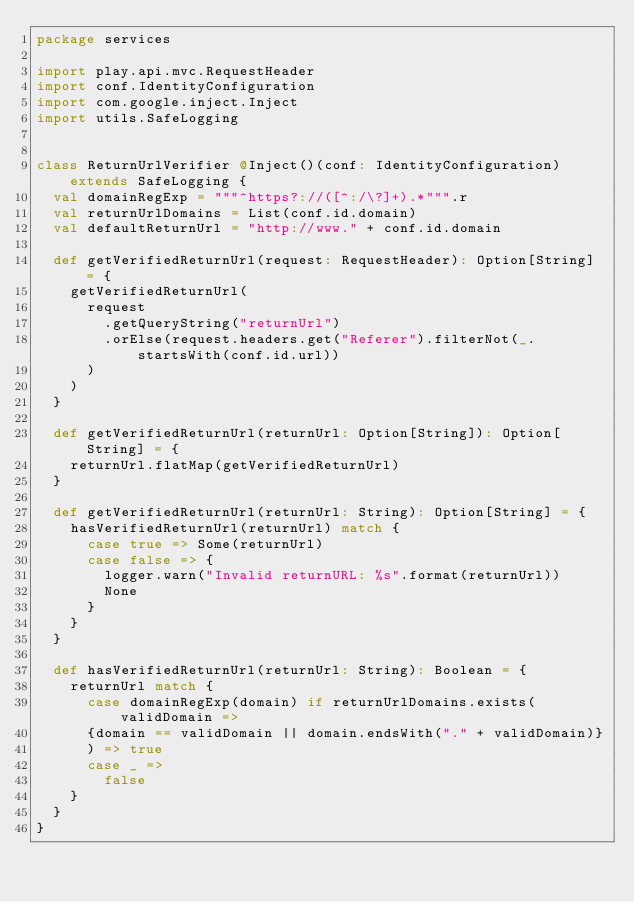<code> <loc_0><loc_0><loc_500><loc_500><_Scala_>package services

import play.api.mvc.RequestHeader
import conf.IdentityConfiguration
import com.google.inject.Inject
import utils.SafeLogging


class ReturnUrlVerifier @Inject()(conf: IdentityConfiguration) extends SafeLogging {
  val domainRegExp = """^https?://([^:/\?]+).*""".r
  val returnUrlDomains = List(conf.id.domain)
  val defaultReturnUrl = "http://www." + conf.id.domain

  def getVerifiedReturnUrl(request: RequestHeader): Option[String] = {
    getVerifiedReturnUrl(
      request
        .getQueryString("returnUrl")
        .orElse(request.headers.get("Referer").filterNot(_.startsWith(conf.id.url))
      )
    )
  }

  def getVerifiedReturnUrl(returnUrl: Option[String]): Option[String] = {
    returnUrl.flatMap(getVerifiedReturnUrl)
  }

  def getVerifiedReturnUrl(returnUrl: String): Option[String] = {
    hasVerifiedReturnUrl(returnUrl) match {
      case true => Some(returnUrl)
      case false => {
        logger.warn("Invalid returnURL: %s".format(returnUrl))
        None
      }
    }
  }

  def hasVerifiedReturnUrl(returnUrl: String): Boolean = {
    returnUrl match {
      case domainRegExp(domain) if returnUrlDomains.exists(validDomain =>
      {domain == validDomain || domain.endsWith("." + validDomain)}
      ) => true
      case _ =>
        false
    }
  }
}
</code> 